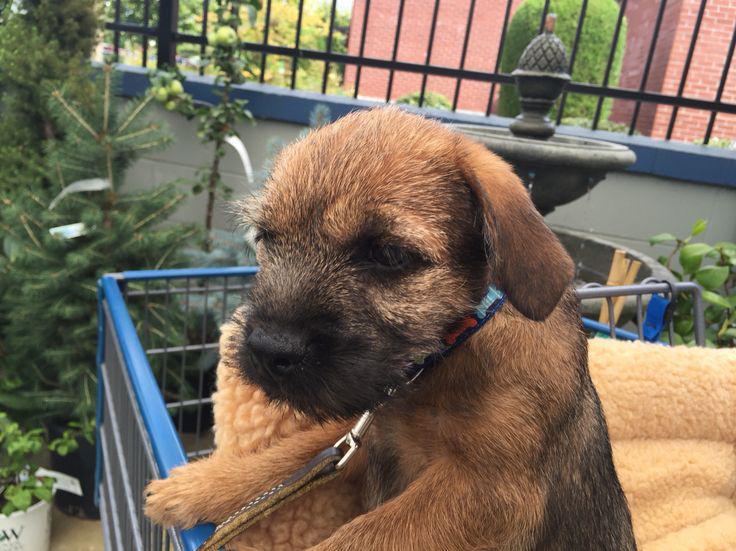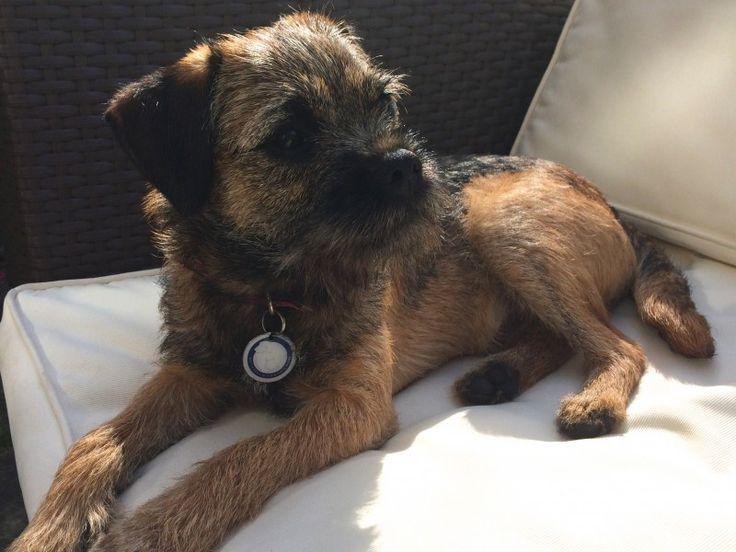The first image is the image on the left, the second image is the image on the right. Analyze the images presented: Is the assertion "Atleast one image contains a sleeping or growling dog." valid? Answer yes or no. No. The first image is the image on the left, the second image is the image on the right. For the images displayed, is the sentence "There is a dog sitting upright inside in the right image." factually correct? Answer yes or no. No. 